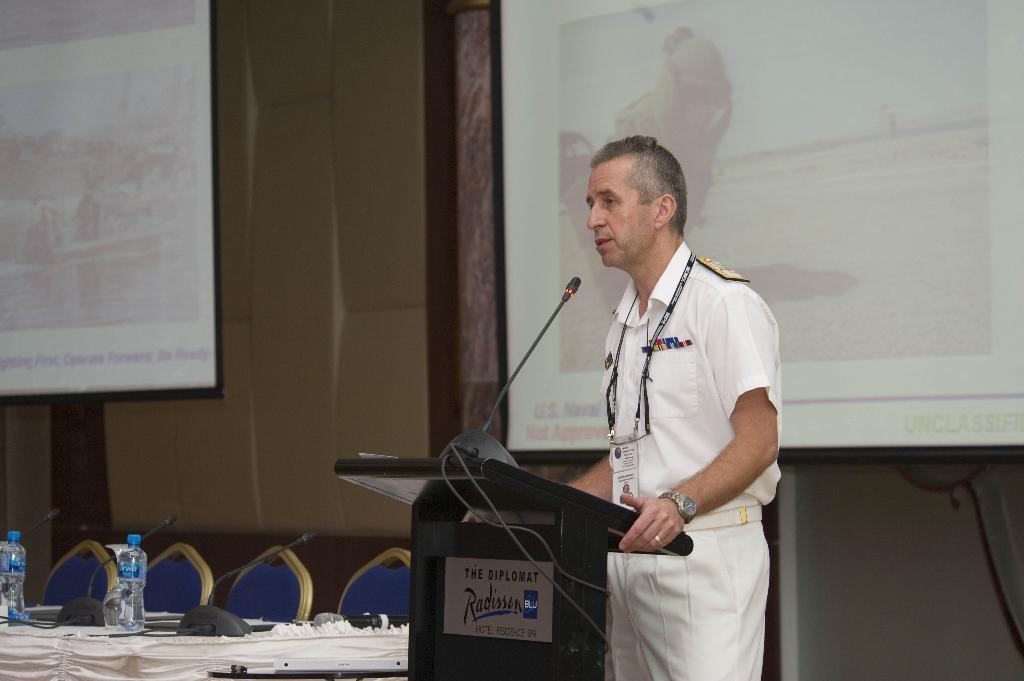Please provide a concise description of this image. There is a man standing, in front of this man we can see microphone on podium. We can see microphones and bottles on the table and we can see chairs. Background we can see screens and wall. 